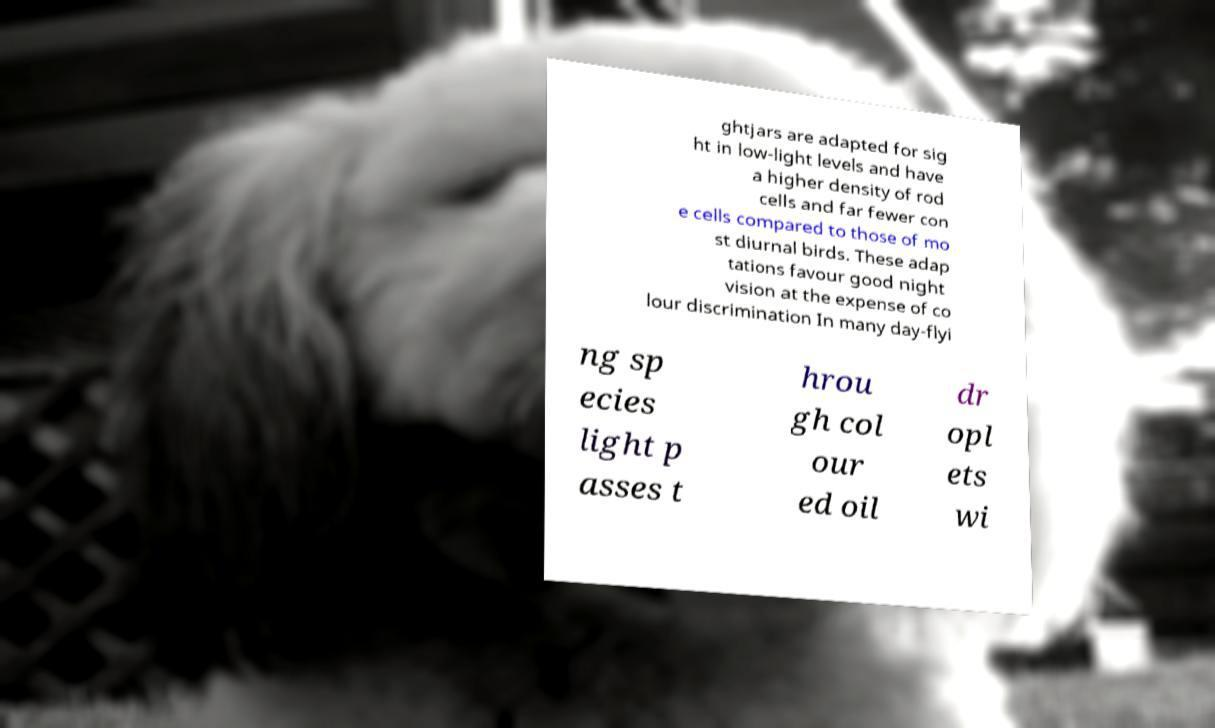I need the written content from this picture converted into text. Can you do that? ghtjars are adapted for sig ht in low-light levels and have a higher density of rod cells and far fewer con e cells compared to those of mo st diurnal birds. These adap tations favour good night vision at the expense of co lour discrimination In many day-flyi ng sp ecies light p asses t hrou gh col our ed oil dr opl ets wi 